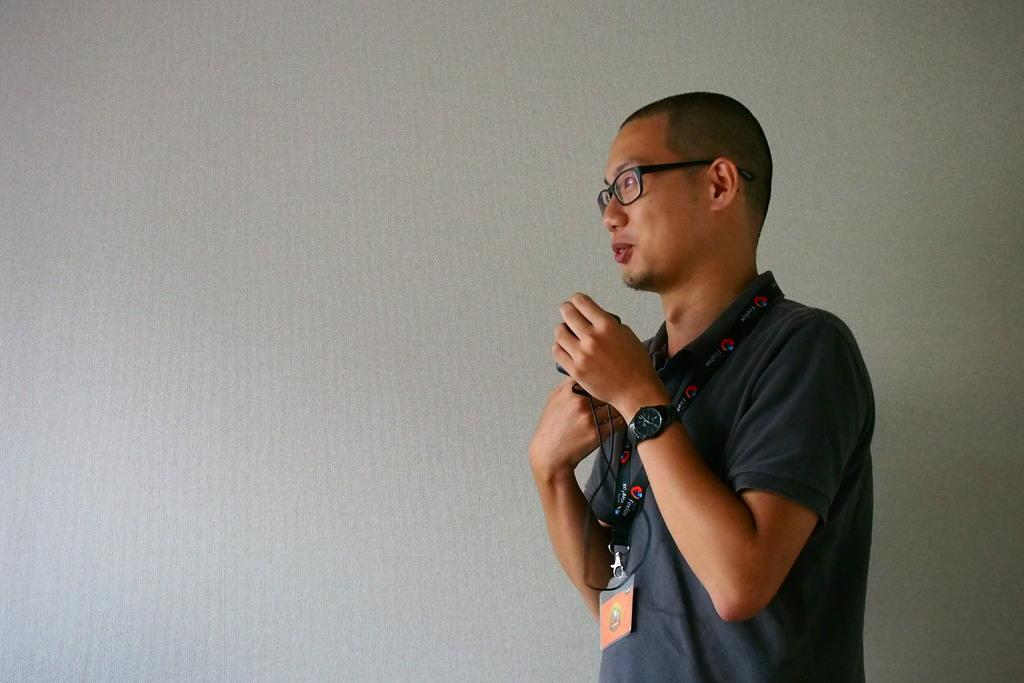What is present in the image? There is a person in the image. What is the person doing in the image? The person is holding some objects. What can be seen in the background of the image? There is a wall visible in the image. What type of spark can be seen coming from the can in the image? There is no can or spark present in the image. How many planes are visible in the image? There are no planes visible in the image. 